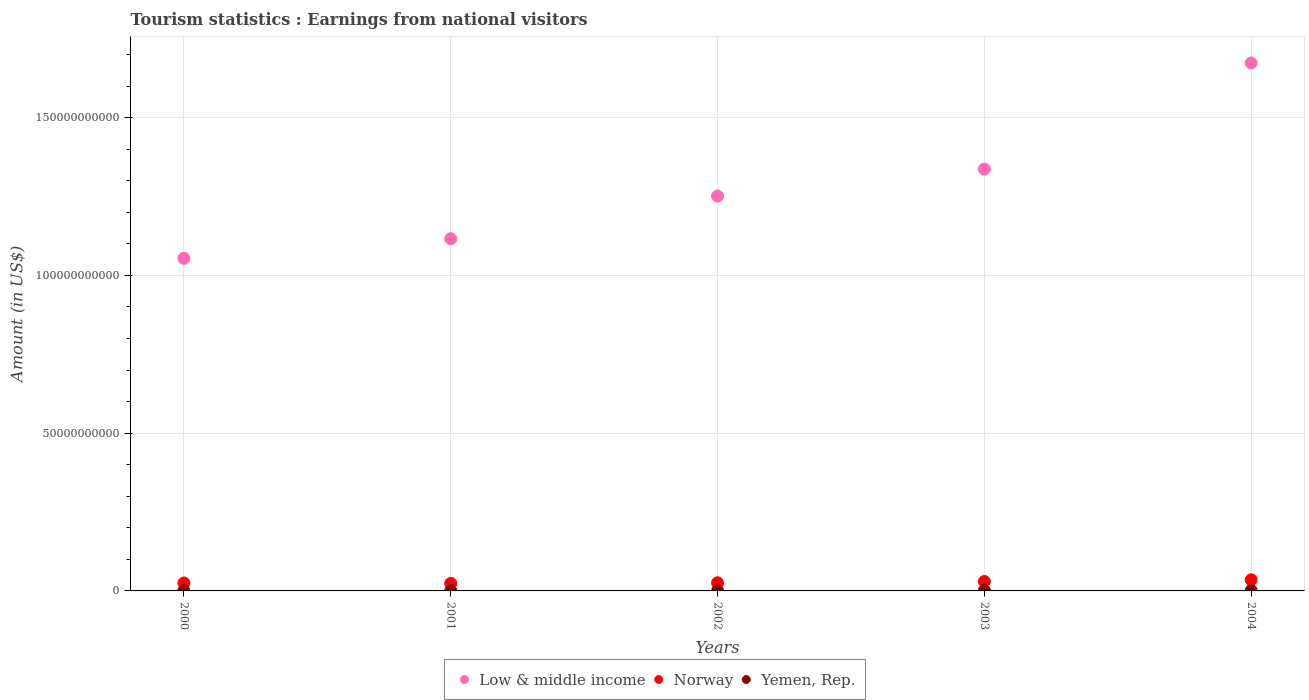How many different coloured dotlines are there?
Offer a very short reply. 3. Is the number of dotlines equal to the number of legend labels?
Your answer should be very brief. Yes. What is the earnings from national visitors in Norway in 2003?
Provide a short and direct response. 2.99e+09. Across all years, what is the maximum earnings from national visitors in Low & middle income?
Provide a succinct answer. 1.67e+11. Across all years, what is the minimum earnings from national visitors in Low & middle income?
Make the answer very short. 1.05e+11. In which year was the earnings from national visitors in Yemen, Rep. minimum?
Your answer should be compact. 2001. What is the total earnings from national visitors in Norway in the graph?
Keep it short and to the point. 1.40e+1. What is the difference between the earnings from national visitors in Yemen, Rep. in 2000 and that in 2003?
Make the answer very short. -6.60e+07. What is the difference between the earnings from national visitors in Low & middle income in 2004 and the earnings from national visitors in Norway in 2001?
Give a very brief answer. 1.65e+11. What is the average earnings from national visitors in Yemen, Rep. per year?
Ensure brevity in your answer.  8.54e+07. In the year 2003, what is the difference between the earnings from national visitors in Low & middle income and earnings from national visitors in Yemen, Rep.?
Offer a terse response. 1.34e+11. What is the ratio of the earnings from national visitors in Yemen, Rep. in 2002 to that in 2003?
Offer a terse response. 0.27. Is the difference between the earnings from national visitors in Low & middle income in 2000 and 2002 greater than the difference between the earnings from national visitors in Yemen, Rep. in 2000 and 2002?
Keep it short and to the point. No. What is the difference between the highest and the second highest earnings from national visitors in Low & middle income?
Provide a short and direct response. 3.36e+1. What is the difference between the highest and the lowest earnings from national visitors in Low & middle income?
Your answer should be compact. 6.19e+1. In how many years, is the earnings from national visitors in Norway greater than the average earnings from national visitors in Norway taken over all years?
Give a very brief answer. 2. Is the sum of the earnings from national visitors in Norway in 2001 and 2004 greater than the maximum earnings from national visitors in Yemen, Rep. across all years?
Provide a succinct answer. Yes. Is it the case that in every year, the sum of the earnings from national visitors in Low & middle income and earnings from national visitors in Norway  is greater than the earnings from national visitors in Yemen, Rep.?
Keep it short and to the point. Yes. How many dotlines are there?
Your answer should be very brief. 3. How many years are there in the graph?
Offer a terse response. 5. Are the values on the major ticks of Y-axis written in scientific E-notation?
Your response must be concise. No. What is the title of the graph?
Keep it short and to the point. Tourism statistics : Earnings from national visitors. What is the Amount (in US$) of Low & middle income in 2000?
Ensure brevity in your answer.  1.05e+11. What is the Amount (in US$) of Norway in 2000?
Ensure brevity in your answer.  2.52e+09. What is the Amount (in US$) of Yemen, Rep. in 2000?
Ensure brevity in your answer.  7.30e+07. What is the Amount (in US$) in Low & middle income in 2001?
Your answer should be compact. 1.12e+11. What is the Amount (in US$) of Norway in 2001?
Offer a terse response. 2.38e+09. What is the Amount (in US$) of Yemen, Rep. in 2001?
Make the answer very short. 3.80e+07. What is the Amount (in US$) of Low & middle income in 2002?
Keep it short and to the point. 1.25e+11. What is the Amount (in US$) of Norway in 2002?
Provide a succinct answer. 2.58e+09. What is the Amount (in US$) in Yemen, Rep. in 2002?
Keep it short and to the point. 3.80e+07. What is the Amount (in US$) in Low & middle income in 2003?
Your response must be concise. 1.34e+11. What is the Amount (in US$) in Norway in 2003?
Ensure brevity in your answer.  2.99e+09. What is the Amount (in US$) of Yemen, Rep. in 2003?
Offer a terse response. 1.39e+08. What is the Amount (in US$) in Low & middle income in 2004?
Offer a very short reply. 1.67e+11. What is the Amount (in US$) of Norway in 2004?
Provide a succinct answer. 3.53e+09. What is the Amount (in US$) in Yemen, Rep. in 2004?
Ensure brevity in your answer.  1.39e+08. Across all years, what is the maximum Amount (in US$) in Low & middle income?
Your answer should be compact. 1.67e+11. Across all years, what is the maximum Amount (in US$) in Norway?
Ensure brevity in your answer.  3.53e+09. Across all years, what is the maximum Amount (in US$) in Yemen, Rep.?
Your answer should be very brief. 1.39e+08. Across all years, what is the minimum Amount (in US$) in Low & middle income?
Make the answer very short. 1.05e+11. Across all years, what is the minimum Amount (in US$) in Norway?
Make the answer very short. 2.38e+09. Across all years, what is the minimum Amount (in US$) of Yemen, Rep.?
Provide a short and direct response. 3.80e+07. What is the total Amount (in US$) of Low & middle income in the graph?
Your answer should be very brief. 6.43e+11. What is the total Amount (in US$) of Norway in the graph?
Provide a short and direct response. 1.40e+1. What is the total Amount (in US$) of Yemen, Rep. in the graph?
Offer a very short reply. 4.27e+08. What is the difference between the Amount (in US$) in Low & middle income in 2000 and that in 2001?
Give a very brief answer. -6.22e+09. What is the difference between the Amount (in US$) in Norway in 2000 and that in 2001?
Give a very brief answer. 1.41e+08. What is the difference between the Amount (in US$) in Yemen, Rep. in 2000 and that in 2001?
Your answer should be very brief. 3.50e+07. What is the difference between the Amount (in US$) in Low & middle income in 2000 and that in 2002?
Give a very brief answer. -1.97e+1. What is the difference between the Amount (in US$) in Norway in 2000 and that in 2002?
Offer a terse response. -6.00e+07. What is the difference between the Amount (in US$) in Yemen, Rep. in 2000 and that in 2002?
Make the answer very short. 3.50e+07. What is the difference between the Amount (in US$) in Low & middle income in 2000 and that in 2003?
Your answer should be very brief. -2.83e+1. What is the difference between the Amount (in US$) of Norway in 2000 and that in 2003?
Provide a succinct answer. -4.68e+08. What is the difference between the Amount (in US$) of Yemen, Rep. in 2000 and that in 2003?
Make the answer very short. -6.60e+07. What is the difference between the Amount (in US$) of Low & middle income in 2000 and that in 2004?
Your answer should be very brief. -6.19e+1. What is the difference between the Amount (in US$) of Norway in 2000 and that in 2004?
Offer a very short reply. -1.01e+09. What is the difference between the Amount (in US$) of Yemen, Rep. in 2000 and that in 2004?
Your response must be concise. -6.60e+07. What is the difference between the Amount (in US$) in Low & middle income in 2001 and that in 2002?
Offer a terse response. -1.35e+1. What is the difference between the Amount (in US$) in Norway in 2001 and that in 2002?
Offer a terse response. -2.01e+08. What is the difference between the Amount (in US$) in Low & middle income in 2001 and that in 2003?
Offer a terse response. -2.21e+1. What is the difference between the Amount (in US$) in Norway in 2001 and that in 2003?
Make the answer very short. -6.09e+08. What is the difference between the Amount (in US$) in Yemen, Rep. in 2001 and that in 2003?
Give a very brief answer. -1.01e+08. What is the difference between the Amount (in US$) in Low & middle income in 2001 and that in 2004?
Make the answer very short. -5.57e+1. What is the difference between the Amount (in US$) of Norway in 2001 and that in 2004?
Make the answer very short. -1.15e+09. What is the difference between the Amount (in US$) of Yemen, Rep. in 2001 and that in 2004?
Offer a terse response. -1.01e+08. What is the difference between the Amount (in US$) in Low & middle income in 2002 and that in 2003?
Ensure brevity in your answer.  -8.56e+09. What is the difference between the Amount (in US$) in Norway in 2002 and that in 2003?
Keep it short and to the point. -4.08e+08. What is the difference between the Amount (in US$) in Yemen, Rep. in 2002 and that in 2003?
Provide a succinct answer. -1.01e+08. What is the difference between the Amount (in US$) in Low & middle income in 2002 and that in 2004?
Provide a succinct answer. -4.22e+1. What is the difference between the Amount (in US$) of Norway in 2002 and that in 2004?
Your response must be concise. -9.50e+08. What is the difference between the Amount (in US$) in Yemen, Rep. in 2002 and that in 2004?
Keep it short and to the point. -1.01e+08. What is the difference between the Amount (in US$) of Low & middle income in 2003 and that in 2004?
Your answer should be very brief. -3.36e+1. What is the difference between the Amount (in US$) in Norway in 2003 and that in 2004?
Provide a short and direct response. -5.42e+08. What is the difference between the Amount (in US$) of Low & middle income in 2000 and the Amount (in US$) of Norway in 2001?
Ensure brevity in your answer.  1.03e+11. What is the difference between the Amount (in US$) of Low & middle income in 2000 and the Amount (in US$) of Yemen, Rep. in 2001?
Give a very brief answer. 1.05e+11. What is the difference between the Amount (in US$) in Norway in 2000 and the Amount (in US$) in Yemen, Rep. in 2001?
Give a very brief answer. 2.48e+09. What is the difference between the Amount (in US$) in Low & middle income in 2000 and the Amount (in US$) in Norway in 2002?
Give a very brief answer. 1.03e+11. What is the difference between the Amount (in US$) of Low & middle income in 2000 and the Amount (in US$) of Yemen, Rep. in 2002?
Keep it short and to the point. 1.05e+11. What is the difference between the Amount (in US$) of Norway in 2000 and the Amount (in US$) of Yemen, Rep. in 2002?
Your response must be concise. 2.48e+09. What is the difference between the Amount (in US$) in Low & middle income in 2000 and the Amount (in US$) in Norway in 2003?
Give a very brief answer. 1.02e+11. What is the difference between the Amount (in US$) in Low & middle income in 2000 and the Amount (in US$) in Yemen, Rep. in 2003?
Offer a very short reply. 1.05e+11. What is the difference between the Amount (in US$) in Norway in 2000 and the Amount (in US$) in Yemen, Rep. in 2003?
Make the answer very short. 2.38e+09. What is the difference between the Amount (in US$) of Low & middle income in 2000 and the Amount (in US$) of Norway in 2004?
Keep it short and to the point. 1.02e+11. What is the difference between the Amount (in US$) in Low & middle income in 2000 and the Amount (in US$) in Yemen, Rep. in 2004?
Keep it short and to the point. 1.05e+11. What is the difference between the Amount (in US$) of Norway in 2000 and the Amount (in US$) of Yemen, Rep. in 2004?
Make the answer very short. 2.38e+09. What is the difference between the Amount (in US$) of Low & middle income in 2001 and the Amount (in US$) of Norway in 2002?
Your response must be concise. 1.09e+11. What is the difference between the Amount (in US$) in Low & middle income in 2001 and the Amount (in US$) in Yemen, Rep. in 2002?
Your answer should be compact. 1.12e+11. What is the difference between the Amount (in US$) of Norway in 2001 and the Amount (in US$) of Yemen, Rep. in 2002?
Ensure brevity in your answer.  2.34e+09. What is the difference between the Amount (in US$) of Low & middle income in 2001 and the Amount (in US$) of Norway in 2003?
Provide a short and direct response. 1.09e+11. What is the difference between the Amount (in US$) in Low & middle income in 2001 and the Amount (in US$) in Yemen, Rep. in 2003?
Keep it short and to the point. 1.11e+11. What is the difference between the Amount (in US$) in Norway in 2001 and the Amount (in US$) in Yemen, Rep. in 2003?
Your response must be concise. 2.24e+09. What is the difference between the Amount (in US$) of Low & middle income in 2001 and the Amount (in US$) of Norway in 2004?
Offer a terse response. 1.08e+11. What is the difference between the Amount (in US$) of Low & middle income in 2001 and the Amount (in US$) of Yemen, Rep. in 2004?
Your answer should be compact. 1.11e+11. What is the difference between the Amount (in US$) in Norway in 2001 and the Amount (in US$) in Yemen, Rep. in 2004?
Provide a short and direct response. 2.24e+09. What is the difference between the Amount (in US$) in Low & middle income in 2002 and the Amount (in US$) in Norway in 2003?
Give a very brief answer. 1.22e+11. What is the difference between the Amount (in US$) in Low & middle income in 2002 and the Amount (in US$) in Yemen, Rep. in 2003?
Give a very brief answer. 1.25e+11. What is the difference between the Amount (in US$) in Norway in 2002 and the Amount (in US$) in Yemen, Rep. in 2003?
Offer a terse response. 2.44e+09. What is the difference between the Amount (in US$) in Low & middle income in 2002 and the Amount (in US$) in Norway in 2004?
Give a very brief answer. 1.22e+11. What is the difference between the Amount (in US$) in Low & middle income in 2002 and the Amount (in US$) in Yemen, Rep. in 2004?
Ensure brevity in your answer.  1.25e+11. What is the difference between the Amount (in US$) in Norway in 2002 and the Amount (in US$) in Yemen, Rep. in 2004?
Give a very brief answer. 2.44e+09. What is the difference between the Amount (in US$) in Low & middle income in 2003 and the Amount (in US$) in Norway in 2004?
Your answer should be very brief. 1.30e+11. What is the difference between the Amount (in US$) of Low & middle income in 2003 and the Amount (in US$) of Yemen, Rep. in 2004?
Provide a succinct answer. 1.34e+11. What is the difference between the Amount (in US$) in Norway in 2003 and the Amount (in US$) in Yemen, Rep. in 2004?
Your answer should be compact. 2.85e+09. What is the average Amount (in US$) of Low & middle income per year?
Offer a very short reply. 1.29e+11. What is the average Amount (in US$) in Norway per year?
Give a very brief answer. 2.80e+09. What is the average Amount (in US$) in Yemen, Rep. per year?
Provide a short and direct response. 8.54e+07. In the year 2000, what is the difference between the Amount (in US$) of Low & middle income and Amount (in US$) of Norway?
Your answer should be compact. 1.03e+11. In the year 2000, what is the difference between the Amount (in US$) of Low & middle income and Amount (in US$) of Yemen, Rep.?
Provide a succinct answer. 1.05e+11. In the year 2000, what is the difference between the Amount (in US$) of Norway and Amount (in US$) of Yemen, Rep.?
Give a very brief answer. 2.45e+09. In the year 2001, what is the difference between the Amount (in US$) in Low & middle income and Amount (in US$) in Norway?
Make the answer very short. 1.09e+11. In the year 2001, what is the difference between the Amount (in US$) in Low & middle income and Amount (in US$) in Yemen, Rep.?
Your response must be concise. 1.12e+11. In the year 2001, what is the difference between the Amount (in US$) of Norway and Amount (in US$) of Yemen, Rep.?
Your answer should be very brief. 2.34e+09. In the year 2002, what is the difference between the Amount (in US$) in Low & middle income and Amount (in US$) in Norway?
Offer a terse response. 1.23e+11. In the year 2002, what is the difference between the Amount (in US$) of Low & middle income and Amount (in US$) of Yemen, Rep.?
Your answer should be compact. 1.25e+11. In the year 2002, what is the difference between the Amount (in US$) of Norway and Amount (in US$) of Yemen, Rep.?
Provide a succinct answer. 2.54e+09. In the year 2003, what is the difference between the Amount (in US$) in Low & middle income and Amount (in US$) in Norway?
Keep it short and to the point. 1.31e+11. In the year 2003, what is the difference between the Amount (in US$) in Low & middle income and Amount (in US$) in Yemen, Rep.?
Provide a short and direct response. 1.34e+11. In the year 2003, what is the difference between the Amount (in US$) of Norway and Amount (in US$) of Yemen, Rep.?
Provide a succinct answer. 2.85e+09. In the year 2004, what is the difference between the Amount (in US$) in Low & middle income and Amount (in US$) in Norway?
Your answer should be compact. 1.64e+11. In the year 2004, what is the difference between the Amount (in US$) in Low & middle income and Amount (in US$) in Yemen, Rep.?
Offer a terse response. 1.67e+11. In the year 2004, what is the difference between the Amount (in US$) in Norway and Amount (in US$) in Yemen, Rep.?
Provide a succinct answer. 3.39e+09. What is the ratio of the Amount (in US$) in Low & middle income in 2000 to that in 2001?
Ensure brevity in your answer.  0.94. What is the ratio of the Amount (in US$) in Norway in 2000 to that in 2001?
Your response must be concise. 1.06. What is the ratio of the Amount (in US$) in Yemen, Rep. in 2000 to that in 2001?
Ensure brevity in your answer.  1.92. What is the ratio of the Amount (in US$) of Low & middle income in 2000 to that in 2002?
Provide a succinct answer. 0.84. What is the ratio of the Amount (in US$) of Norway in 2000 to that in 2002?
Ensure brevity in your answer.  0.98. What is the ratio of the Amount (in US$) of Yemen, Rep. in 2000 to that in 2002?
Your answer should be very brief. 1.92. What is the ratio of the Amount (in US$) in Low & middle income in 2000 to that in 2003?
Ensure brevity in your answer.  0.79. What is the ratio of the Amount (in US$) in Norway in 2000 to that in 2003?
Provide a succinct answer. 0.84. What is the ratio of the Amount (in US$) of Yemen, Rep. in 2000 to that in 2003?
Offer a very short reply. 0.53. What is the ratio of the Amount (in US$) of Low & middle income in 2000 to that in 2004?
Give a very brief answer. 0.63. What is the ratio of the Amount (in US$) of Norway in 2000 to that in 2004?
Provide a short and direct response. 0.71. What is the ratio of the Amount (in US$) in Yemen, Rep. in 2000 to that in 2004?
Give a very brief answer. 0.53. What is the ratio of the Amount (in US$) in Low & middle income in 2001 to that in 2002?
Your response must be concise. 0.89. What is the ratio of the Amount (in US$) of Norway in 2001 to that in 2002?
Your response must be concise. 0.92. What is the ratio of the Amount (in US$) in Yemen, Rep. in 2001 to that in 2002?
Provide a succinct answer. 1. What is the ratio of the Amount (in US$) of Low & middle income in 2001 to that in 2003?
Ensure brevity in your answer.  0.83. What is the ratio of the Amount (in US$) of Norway in 2001 to that in 2003?
Your response must be concise. 0.8. What is the ratio of the Amount (in US$) in Yemen, Rep. in 2001 to that in 2003?
Your answer should be very brief. 0.27. What is the ratio of the Amount (in US$) in Low & middle income in 2001 to that in 2004?
Make the answer very short. 0.67. What is the ratio of the Amount (in US$) of Norway in 2001 to that in 2004?
Ensure brevity in your answer.  0.67. What is the ratio of the Amount (in US$) of Yemen, Rep. in 2001 to that in 2004?
Give a very brief answer. 0.27. What is the ratio of the Amount (in US$) of Low & middle income in 2002 to that in 2003?
Make the answer very short. 0.94. What is the ratio of the Amount (in US$) in Norway in 2002 to that in 2003?
Provide a succinct answer. 0.86. What is the ratio of the Amount (in US$) in Yemen, Rep. in 2002 to that in 2003?
Make the answer very short. 0.27. What is the ratio of the Amount (in US$) in Low & middle income in 2002 to that in 2004?
Your response must be concise. 0.75. What is the ratio of the Amount (in US$) of Norway in 2002 to that in 2004?
Your answer should be very brief. 0.73. What is the ratio of the Amount (in US$) in Yemen, Rep. in 2002 to that in 2004?
Your answer should be compact. 0.27. What is the ratio of the Amount (in US$) in Low & middle income in 2003 to that in 2004?
Make the answer very short. 0.8. What is the ratio of the Amount (in US$) in Norway in 2003 to that in 2004?
Your answer should be very brief. 0.85. What is the difference between the highest and the second highest Amount (in US$) in Low & middle income?
Give a very brief answer. 3.36e+1. What is the difference between the highest and the second highest Amount (in US$) in Norway?
Offer a very short reply. 5.42e+08. What is the difference between the highest and the lowest Amount (in US$) in Low & middle income?
Give a very brief answer. 6.19e+1. What is the difference between the highest and the lowest Amount (in US$) in Norway?
Provide a short and direct response. 1.15e+09. What is the difference between the highest and the lowest Amount (in US$) of Yemen, Rep.?
Your response must be concise. 1.01e+08. 